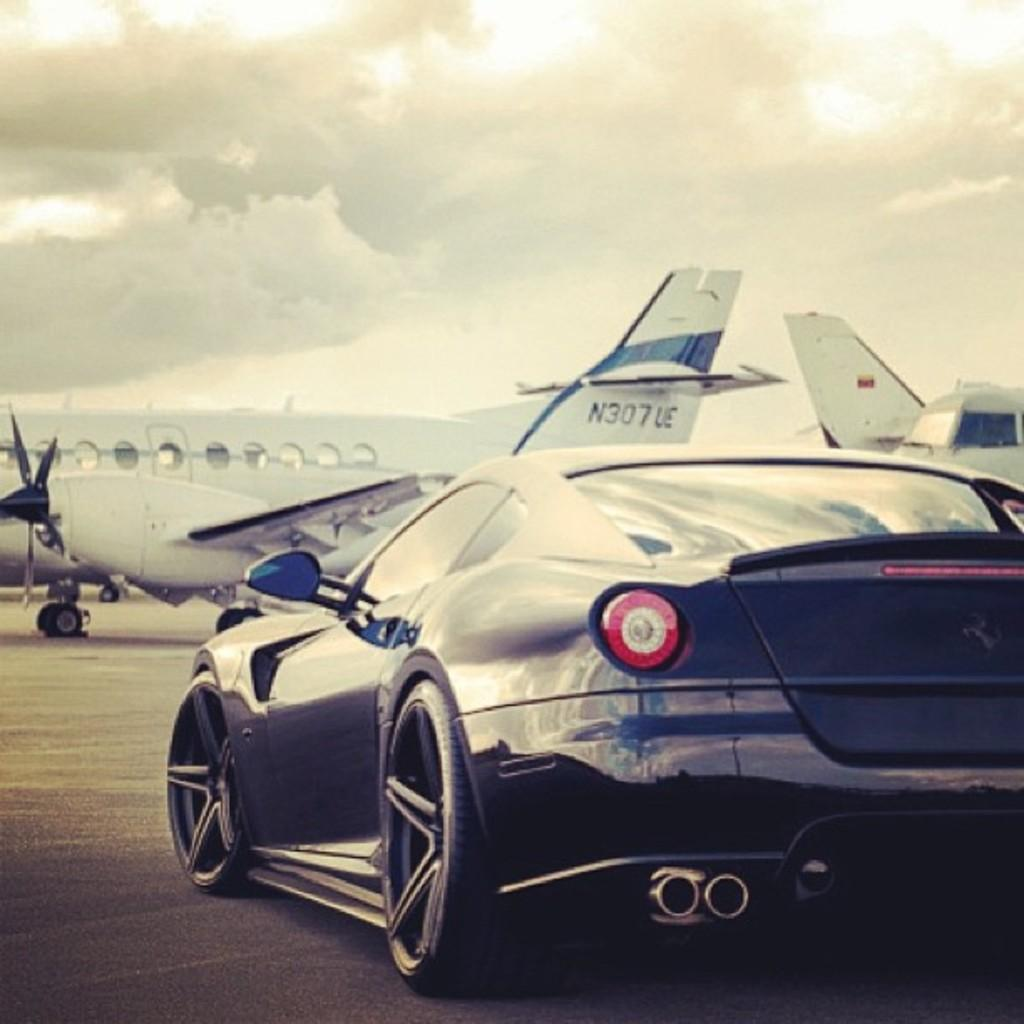<image>
Give a short and clear explanation of the subsequent image. A black car sits beside an airplane with N307UE on the tail. 